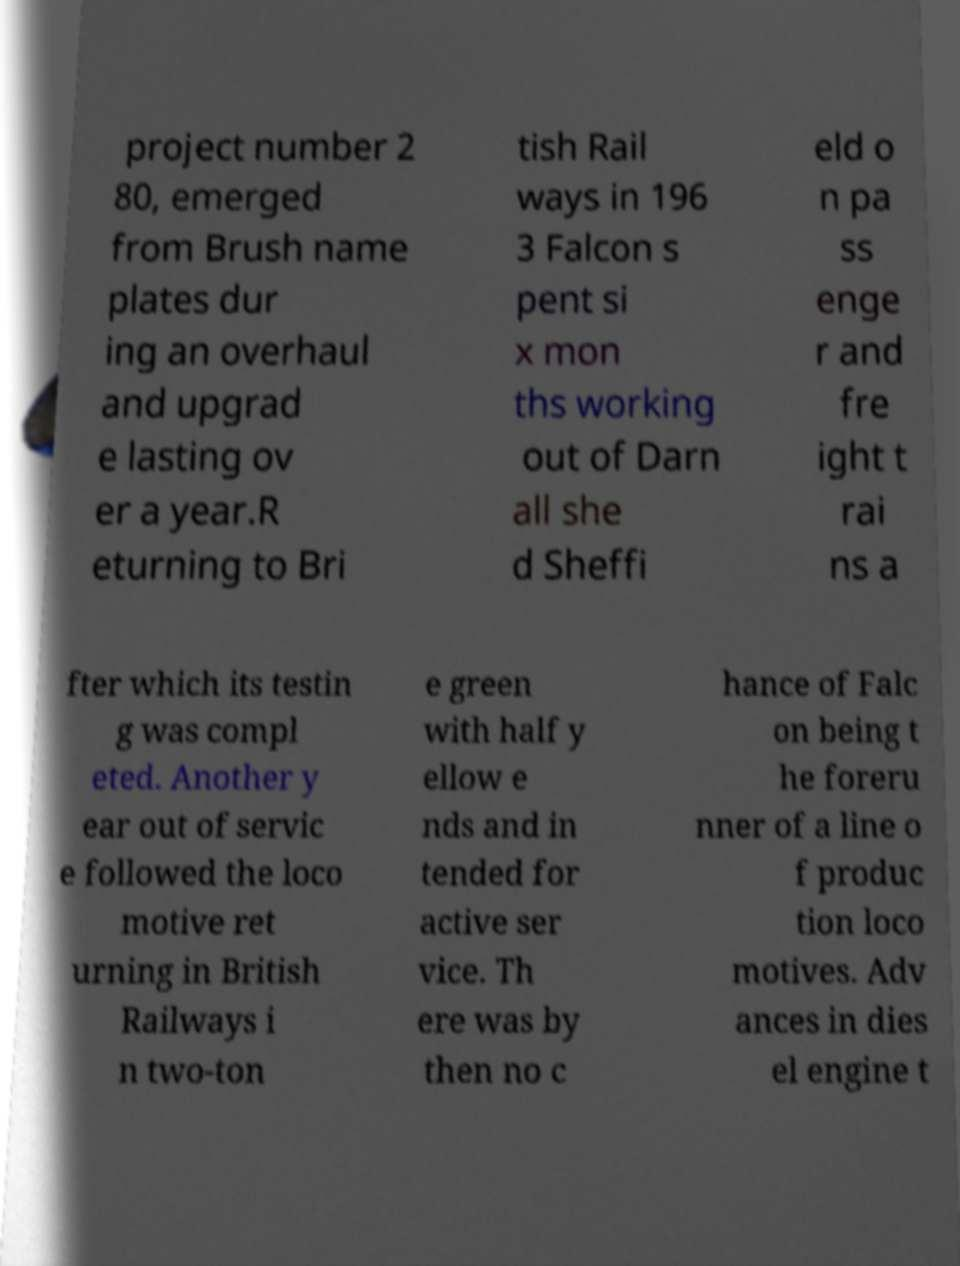What messages or text are displayed in this image? I need them in a readable, typed format. project number 2 80, emerged from Brush name plates dur ing an overhaul and upgrad e lasting ov er a year.R eturning to Bri tish Rail ways in 196 3 Falcon s pent si x mon ths working out of Darn all she d Sheffi eld o n pa ss enge r and fre ight t rai ns a fter which its testin g was compl eted. Another y ear out of servic e followed the loco motive ret urning in British Railways i n two-ton e green with half y ellow e nds and in tended for active ser vice. Th ere was by then no c hance of Falc on being t he foreru nner of a line o f produc tion loco motives. Adv ances in dies el engine t 